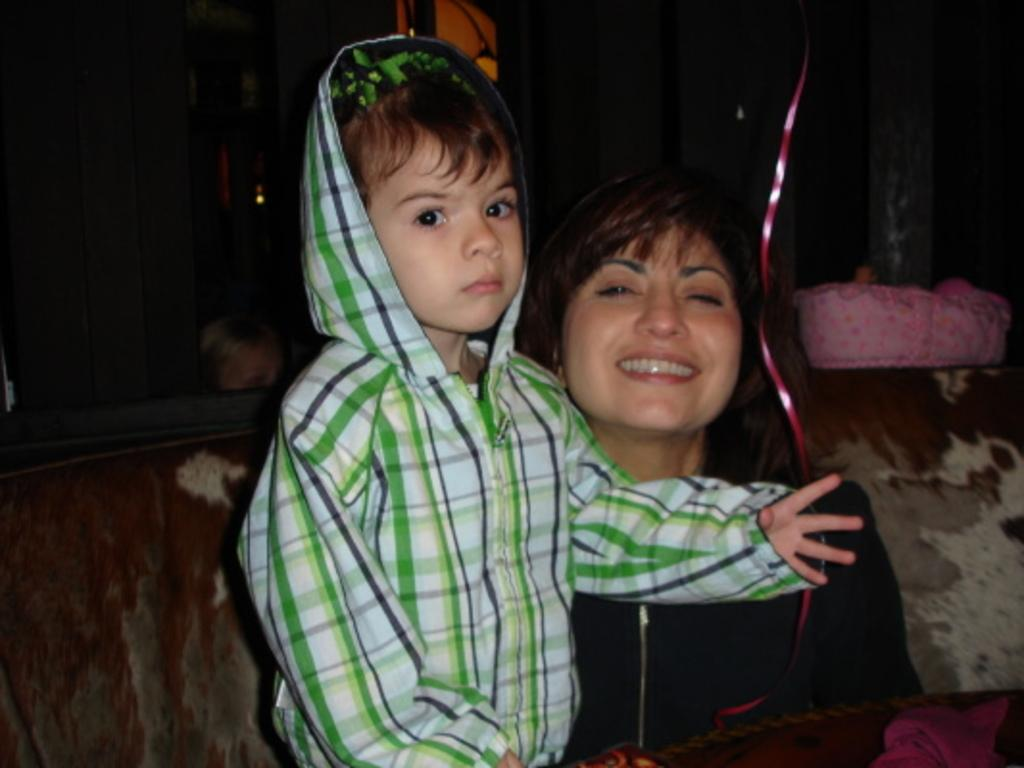Who are the main subjects in the image? There is a lady and a small boy in the image. Where are the lady and the small boy located in the image? Both the lady and the small boy are in the center of the image. What type of foot can be seen on the cherry in the image? There is no cherry or foot present in the image. 